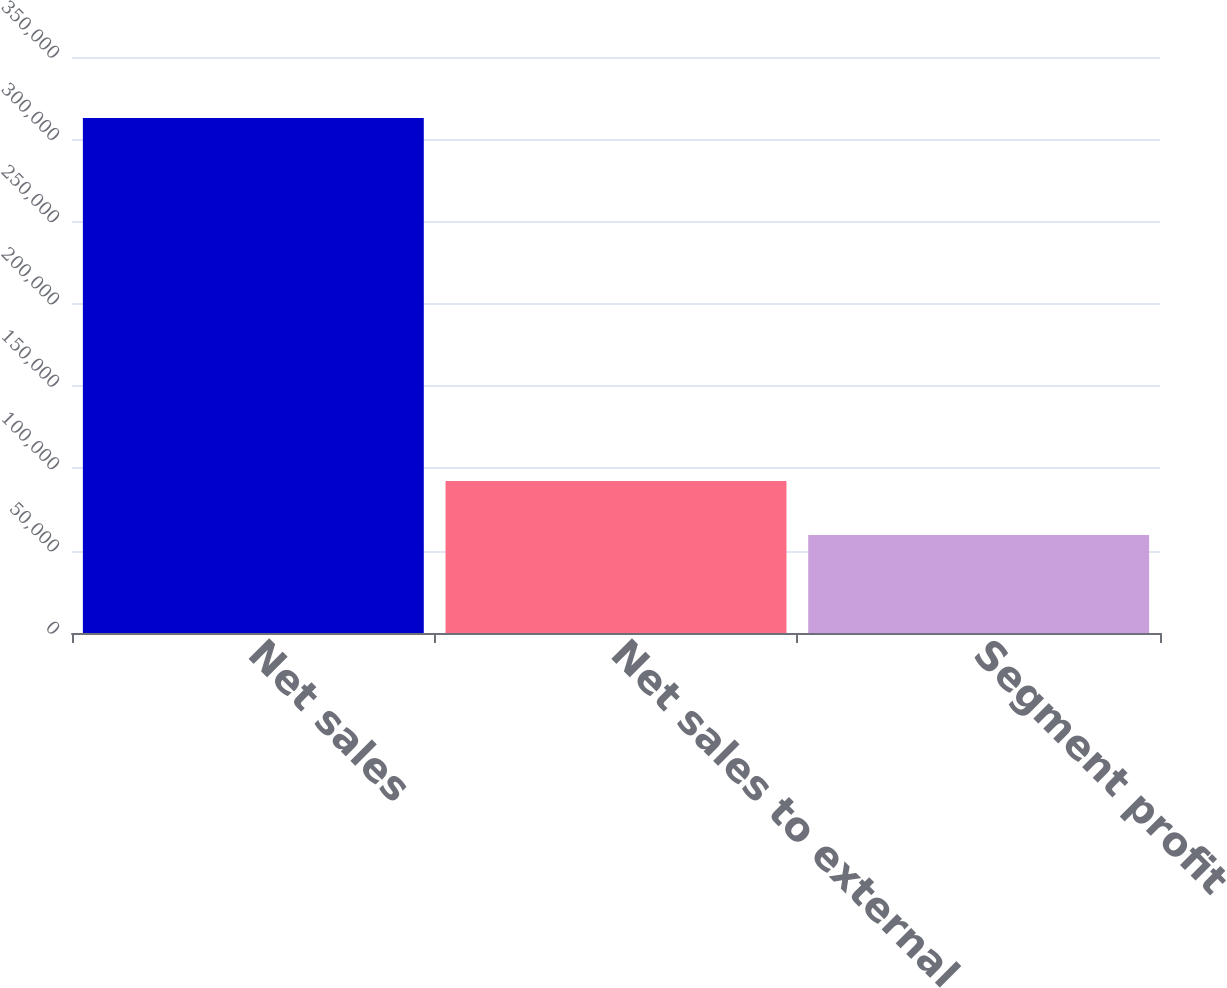Convert chart to OTSL. <chart><loc_0><loc_0><loc_500><loc_500><bar_chart><fcel>Net sales<fcel>Net sales to external<fcel>Segment profit<nl><fcel>312992<fcel>92321<fcel>59576<nl></chart> 